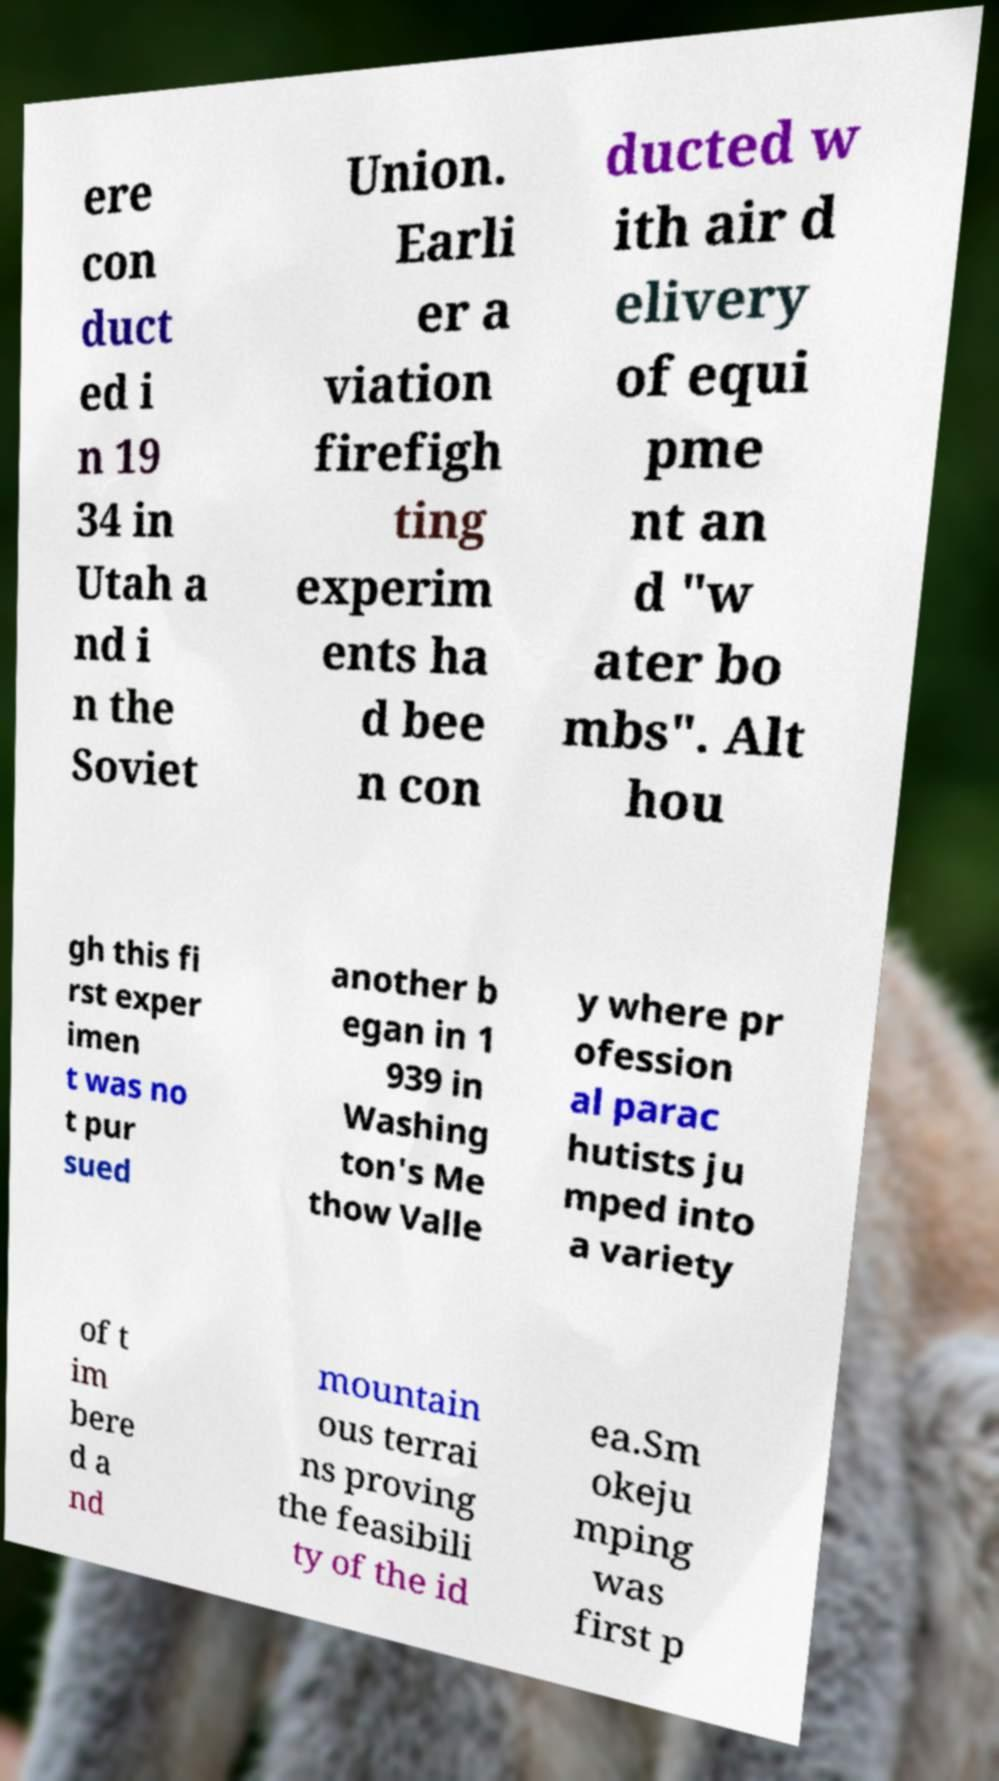For documentation purposes, I need the text within this image transcribed. Could you provide that? ere con duct ed i n 19 34 in Utah a nd i n the Soviet Union. Earli er a viation firefigh ting experim ents ha d bee n con ducted w ith air d elivery of equi pme nt an d "w ater bo mbs". Alt hou gh this fi rst exper imen t was no t pur sued another b egan in 1 939 in Washing ton's Me thow Valle y where pr ofession al parac hutists ju mped into a variety of t im bere d a nd mountain ous terrai ns proving the feasibili ty of the id ea.Sm okeju mping was first p 